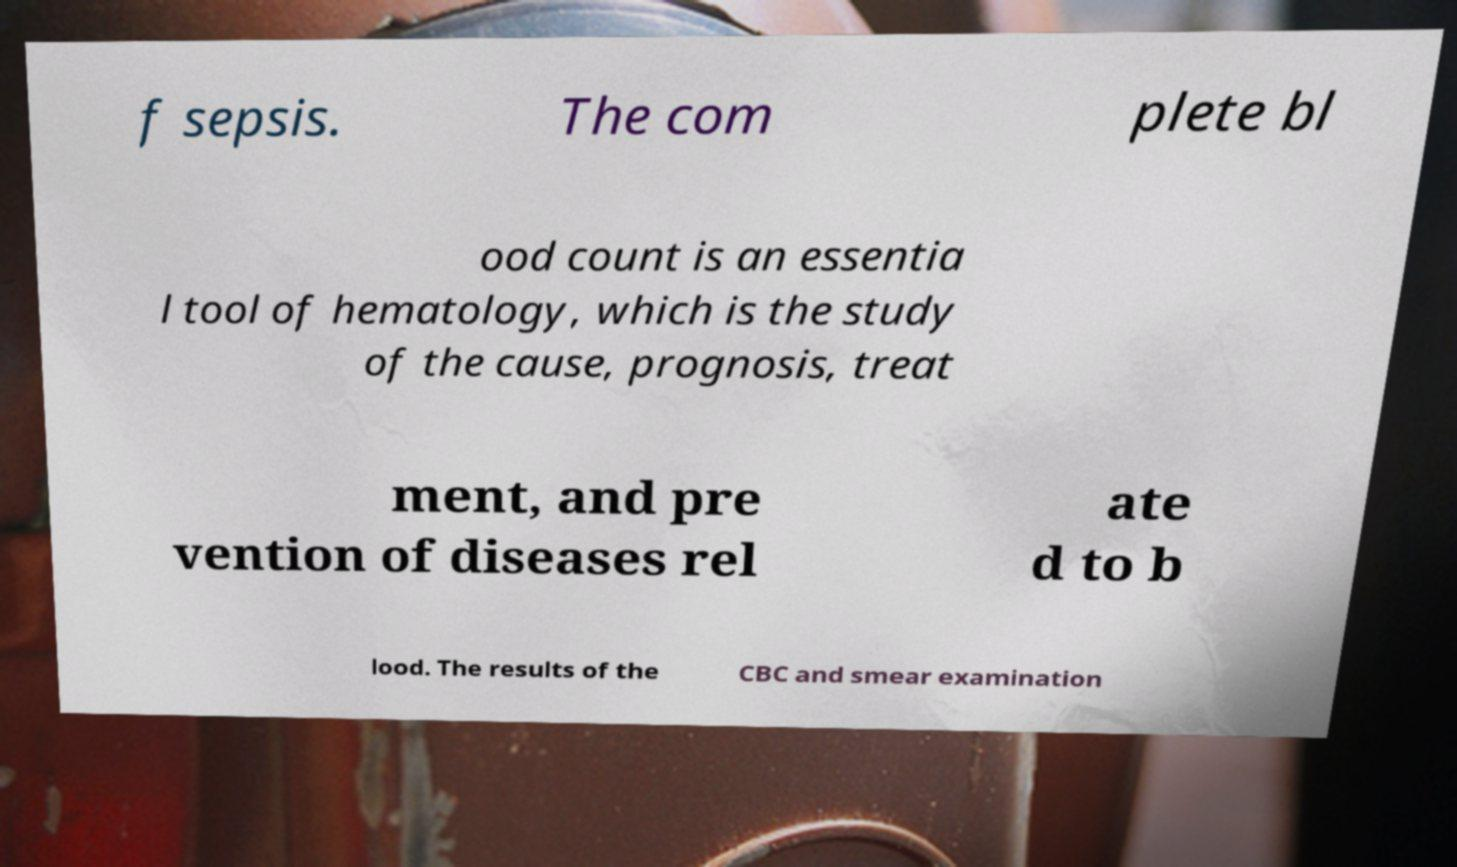Can you accurately transcribe the text from the provided image for me? f sepsis. The com plete bl ood count is an essentia l tool of hematology, which is the study of the cause, prognosis, treat ment, and pre vention of diseases rel ate d to b lood. The results of the CBC and smear examination 